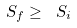<formula> <loc_0><loc_0><loc_500><loc_500>S _ { f } \geq \ S _ { i }</formula> 